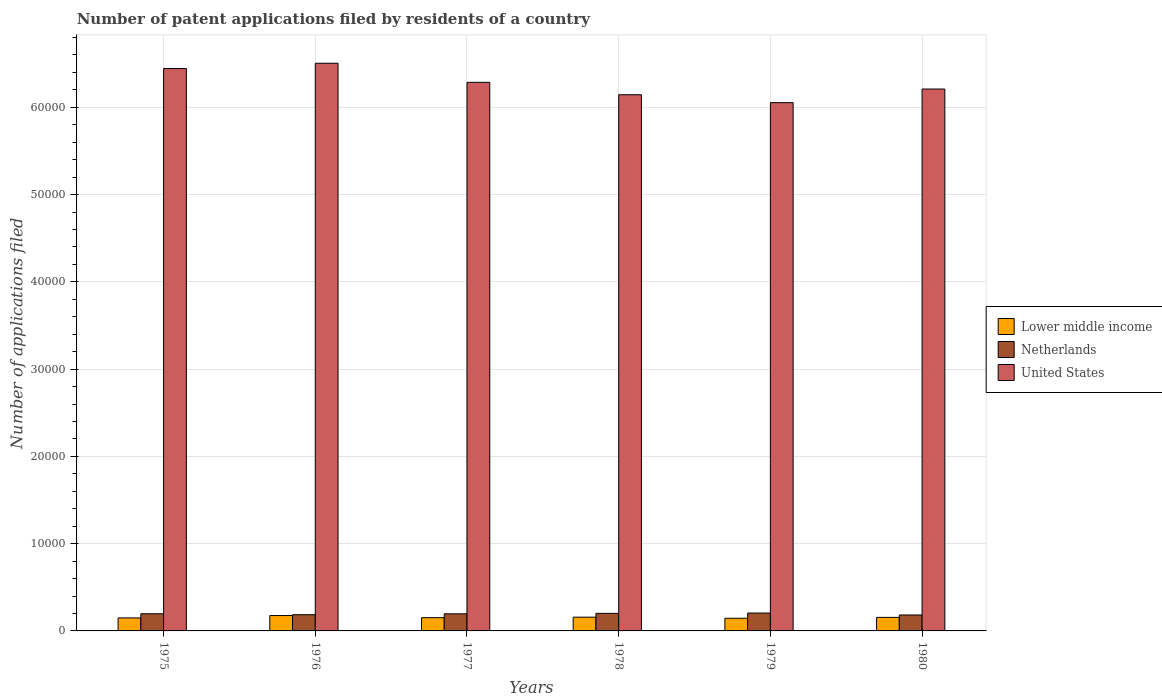How many groups of bars are there?
Make the answer very short. 6. Are the number of bars per tick equal to the number of legend labels?
Your answer should be compact. Yes. Are the number of bars on each tick of the X-axis equal?
Make the answer very short. Yes. What is the label of the 4th group of bars from the left?
Your response must be concise. 1978. In how many cases, is the number of bars for a given year not equal to the number of legend labels?
Your answer should be very brief. 0. What is the number of applications filed in Netherlands in 1976?
Give a very brief answer. 1857. Across all years, what is the maximum number of applications filed in Netherlands?
Ensure brevity in your answer.  2049. Across all years, what is the minimum number of applications filed in Lower middle income?
Provide a short and direct response. 1452. In which year was the number of applications filed in United States maximum?
Ensure brevity in your answer.  1976. In which year was the number of applications filed in United States minimum?
Your response must be concise. 1979. What is the total number of applications filed in Lower middle income in the graph?
Your answer should be compact. 9347. What is the difference between the number of applications filed in Lower middle income in 1975 and that in 1976?
Offer a terse response. -273. What is the difference between the number of applications filed in United States in 1980 and the number of applications filed in Netherlands in 1979?
Keep it short and to the point. 6.00e+04. What is the average number of applications filed in Lower middle income per year?
Your answer should be compact. 1557.83. In the year 1977, what is the difference between the number of applications filed in Netherlands and number of applications filed in United States?
Your answer should be very brief. -6.09e+04. In how many years, is the number of applications filed in United States greater than 16000?
Offer a very short reply. 6. What is the ratio of the number of applications filed in Lower middle income in 1977 to that in 1978?
Give a very brief answer. 0.96. Is the number of applications filed in Netherlands in 1978 less than that in 1979?
Offer a very short reply. Yes. Is the difference between the number of applications filed in Netherlands in 1976 and 1977 greater than the difference between the number of applications filed in United States in 1976 and 1977?
Make the answer very short. No. What is the difference between the highest and the lowest number of applications filed in Netherlands?
Make the answer very short. 223. Is the sum of the number of applications filed in Netherlands in 1977 and 1980 greater than the maximum number of applications filed in United States across all years?
Provide a succinct answer. No. What does the 2nd bar from the left in 1977 represents?
Provide a succinct answer. Netherlands. What does the 3rd bar from the right in 1977 represents?
Provide a short and direct response. Lower middle income. Are all the bars in the graph horizontal?
Keep it short and to the point. No. What is the difference between two consecutive major ticks on the Y-axis?
Ensure brevity in your answer.  10000. Are the values on the major ticks of Y-axis written in scientific E-notation?
Give a very brief answer. No. Where does the legend appear in the graph?
Provide a succinct answer. Center right. How are the legend labels stacked?
Your answer should be very brief. Vertical. What is the title of the graph?
Provide a short and direct response. Number of patent applications filed by residents of a country. Does "Andorra" appear as one of the legend labels in the graph?
Make the answer very short. No. What is the label or title of the Y-axis?
Provide a succinct answer. Number of applications filed. What is the Number of applications filed of Lower middle income in 1975?
Offer a very short reply. 1489. What is the Number of applications filed of Netherlands in 1975?
Keep it short and to the point. 1966. What is the Number of applications filed of United States in 1975?
Keep it short and to the point. 6.44e+04. What is the Number of applications filed in Lower middle income in 1976?
Ensure brevity in your answer.  1762. What is the Number of applications filed of Netherlands in 1976?
Your response must be concise. 1857. What is the Number of applications filed in United States in 1976?
Make the answer very short. 6.50e+04. What is the Number of applications filed in Lower middle income in 1977?
Keep it short and to the point. 1517. What is the Number of applications filed in Netherlands in 1977?
Offer a terse response. 1960. What is the Number of applications filed of United States in 1977?
Keep it short and to the point. 6.29e+04. What is the Number of applications filed of Lower middle income in 1978?
Give a very brief answer. 1575. What is the Number of applications filed of Netherlands in 1978?
Give a very brief answer. 2011. What is the Number of applications filed of United States in 1978?
Your answer should be very brief. 6.14e+04. What is the Number of applications filed of Lower middle income in 1979?
Provide a short and direct response. 1452. What is the Number of applications filed in Netherlands in 1979?
Provide a short and direct response. 2049. What is the Number of applications filed in United States in 1979?
Provide a succinct answer. 6.05e+04. What is the Number of applications filed of Lower middle income in 1980?
Your answer should be very brief. 1552. What is the Number of applications filed in Netherlands in 1980?
Your answer should be very brief. 1826. What is the Number of applications filed of United States in 1980?
Keep it short and to the point. 6.21e+04. Across all years, what is the maximum Number of applications filed in Lower middle income?
Keep it short and to the point. 1762. Across all years, what is the maximum Number of applications filed in Netherlands?
Give a very brief answer. 2049. Across all years, what is the maximum Number of applications filed of United States?
Your answer should be very brief. 6.50e+04. Across all years, what is the minimum Number of applications filed of Lower middle income?
Ensure brevity in your answer.  1452. Across all years, what is the minimum Number of applications filed of Netherlands?
Your answer should be very brief. 1826. Across all years, what is the minimum Number of applications filed in United States?
Provide a short and direct response. 6.05e+04. What is the total Number of applications filed of Lower middle income in the graph?
Your response must be concise. 9347. What is the total Number of applications filed of Netherlands in the graph?
Provide a short and direct response. 1.17e+04. What is the total Number of applications filed in United States in the graph?
Provide a succinct answer. 3.76e+05. What is the difference between the Number of applications filed of Lower middle income in 1975 and that in 1976?
Provide a short and direct response. -273. What is the difference between the Number of applications filed in Netherlands in 1975 and that in 1976?
Ensure brevity in your answer.  109. What is the difference between the Number of applications filed in United States in 1975 and that in 1976?
Make the answer very short. -605. What is the difference between the Number of applications filed of United States in 1975 and that in 1977?
Offer a very short reply. 1582. What is the difference between the Number of applications filed in Lower middle income in 1975 and that in 1978?
Make the answer very short. -86. What is the difference between the Number of applications filed of Netherlands in 1975 and that in 1978?
Make the answer very short. -45. What is the difference between the Number of applications filed in United States in 1975 and that in 1978?
Give a very brief answer. 3004. What is the difference between the Number of applications filed of Lower middle income in 1975 and that in 1979?
Your answer should be compact. 37. What is the difference between the Number of applications filed of Netherlands in 1975 and that in 1979?
Your answer should be compact. -83. What is the difference between the Number of applications filed in United States in 1975 and that in 1979?
Give a very brief answer. 3910. What is the difference between the Number of applications filed of Lower middle income in 1975 and that in 1980?
Your answer should be compact. -63. What is the difference between the Number of applications filed of Netherlands in 1975 and that in 1980?
Provide a succinct answer. 140. What is the difference between the Number of applications filed of United States in 1975 and that in 1980?
Ensure brevity in your answer.  2347. What is the difference between the Number of applications filed in Lower middle income in 1976 and that in 1977?
Keep it short and to the point. 245. What is the difference between the Number of applications filed in Netherlands in 1976 and that in 1977?
Make the answer very short. -103. What is the difference between the Number of applications filed of United States in 1976 and that in 1977?
Offer a very short reply. 2187. What is the difference between the Number of applications filed in Lower middle income in 1976 and that in 1978?
Offer a terse response. 187. What is the difference between the Number of applications filed of Netherlands in 1976 and that in 1978?
Offer a very short reply. -154. What is the difference between the Number of applications filed of United States in 1976 and that in 1978?
Keep it short and to the point. 3609. What is the difference between the Number of applications filed of Lower middle income in 1976 and that in 1979?
Your answer should be very brief. 310. What is the difference between the Number of applications filed in Netherlands in 1976 and that in 1979?
Make the answer very short. -192. What is the difference between the Number of applications filed of United States in 1976 and that in 1979?
Your answer should be compact. 4515. What is the difference between the Number of applications filed of Lower middle income in 1976 and that in 1980?
Ensure brevity in your answer.  210. What is the difference between the Number of applications filed of United States in 1976 and that in 1980?
Offer a very short reply. 2952. What is the difference between the Number of applications filed in Lower middle income in 1977 and that in 1978?
Your answer should be compact. -58. What is the difference between the Number of applications filed of Netherlands in 1977 and that in 1978?
Offer a very short reply. -51. What is the difference between the Number of applications filed of United States in 1977 and that in 1978?
Offer a terse response. 1422. What is the difference between the Number of applications filed of Lower middle income in 1977 and that in 1979?
Offer a very short reply. 65. What is the difference between the Number of applications filed in Netherlands in 1977 and that in 1979?
Your answer should be very brief. -89. What is the difference between the Number of applications filed of United States in 1977 and that in 1979?
Keep it short and to the point. 2328. What is the difference between the Number of applications filed of Lower middle income in 1977 and that in 1980?
Provide a short and direct response. -35. What is the difference between the Number of applications filed in Netherlands in 1977 and that in 1980?
Your response must be concise. 134. What is the difference between the Number of applications filed of United States in 1977 and that in 1980?
Offer a very short reply. 765. What is the difference between the Number of applications filed in Lower middle income in 1978 and that in 1979?
Provide a succinct answer. 123. What is the difference between the Number of applications filed in Netherlands in 1978 and that in 1979?
Offer a terse response. -38. What is the difference between the Number of applications filed in United States in 1978 and that in 1979?
Your response must be concise. 906. What is the difference between the Number of applications filed in Lower middle income in 1978 and that in 1980?
Give a very brief answer. 23. What is the difference between the Number of applications filed in Netherlands in 1978 and that in 1980?
Offer a terse response. 185. What is the difference between the Number of applications filed of United States in 1978 and that in 1980?
Your response must be concise. -657. What is the difference between the Number of applications filed of Lower middle income in 1979 and that in 1980?
Ensure brevity in your answer.  -100. What is the difference between the Number of applications filed of Netherlands in 1979 and that in 1980?
Ensure brevity in your answer.  223. What is the difference between the Number of applications filed in United States in 1979 and that in 1980?
Provide a succinct answer. -1563. What is the difference between the Number of applications filed in Lower middle income in 1975 and the Number of applications filed in Netherlands in 1976?
Offer a very short reply. -368. What is the difference between the Number of applications filed in Lower middle income in 1975 and the Number of applications filed in United States in 1976?
Provide a succinct answer. -6.36e+04. What is the difference between the Number of applications filed in Netherlands in 1975 and the Number of applications filed in United States in 1976?
Offer a terse response. -6.31e+04. What is the difference between the Number of applications filed of Lower middle income in 1975 and the Number of applications filed of Netherlands in 1977?
Your response must be concise. -471. What is the difference between the Number of applications filed of Lower middle income in 1975 and the Number of applications filed of United States in 1977?
Your answer should be compact. -6.14e+04. What is the difference between the Number of applications filed in Netherlands in 1975 and the Number of applications filed in United States in 1977?
Your answer should be compact. -6.09e+04. What is the difference between the Number of applications filed in Lower middle income in 1975 and the Number of applications filed in Netherlands in 1978?
Keep it short and to the point. -522. What is the difference between the Number of applications filed of Lower middle income in 1975 and the Number of applications filed of United States in 1978?
Ensure brevity in your answer.  -6.00e+04. What is the difference between the Number of applications filed in Netherlands in 1975 and the Number of applications filed in United States in 1978?
Offer a very short reply. -5.95e+04. What is the difference between the Number of applications filed in Lower middle income in 1975 and the Number of applications filed in Netherlands in 1979?
Your answer should be very brief. -560. What is the difference between the Number of applications filed of Lower middle income in 1975 and the Number of applications filed of United States in 1979?
Keep it short and to the point. -5.90e+04. What is the difference between the Number of applications filed in Netherlands in 1975 and the Number of applications filed in United States in 1979?
Provide a succinct answer. -5.86e+04. What is the difference between the Number of applications filed of Lower middle income in 1975 and the Number of applications filed of Netherlands in 1980?
Offer a terse response. -337. What is the difference between the Number of applications filed in Lower middle income in 1975 and the Number of applications filed in United States in 1980?
Make the answer very short. -6.06e+04. What is the difference between the Number of applications filed of Netherlands in 1975 and the Number of applications filed of United States in 1980?
Keep it short and to the point. -6.01e+04. What is the difference between the Number of applications filed of Lower middle income in 1976 and the Number of applications filed of Netherlands in 1977?
Offer a terse response. -198. What is the difference between the Number of applications filed in Lower middle income in 1976 and the Number of applications filed in United States in 1977?
Your answer should be very brief. -6.11e+04. What is the difference between the Number of applications filed of Netherlands in 1976 and the Number of applications filed of United States in 1977?
Make the answer very short. -6.10e+04. What is the difference between the Number of applications filed of Lower middle income in 1976 and the Number of applications filed of Netherlands in 1978?
Your answer should be compact. -249. What is the difference between the Number of applications filed in Lower middle income in 1976 and the Number of applications filed in United States in 1978?
Your response must be concise. -5.97e+04. What is the difference between the Number of applications filed in Netherlands in 1976 and the Number of applications filed in United States in 1978?
Provide a short and direct response. -5.96e+04. What is the difference between the Number of applications filed of Lower middle income in 1976 and the Number of applications filed of Netherlands in 1979?
Give a very brief answer. -287. What is the difference between the Number of applications filed in Lower middle income in 1976 and the Number of applications filed in United States in 1979?
Your answer should be compact. -5.88e+04. What is the difference between the Number of applications filed of Netherlands in 1976 and the Number of applications filed of United States in 1979?
Your answer should be very brief. -5.87e+04. What is the difference between the Number of applications filed in Lower middle income in 1976 and the Number of applications filed in Netherlands in 1980?
Your answer should be very brief. -64. What is the difference between the Number of applications filed in Lower middle income in 1976 and the Number of applications filed in United States in 1980?
Your response must be concise. -6.03e+04. What is the difference between the Number of applications filed in Netherlands in 1976 and the Number of applications filed in United States in 1980?
Your answer should be compact. -6.02e+04. What is the difference between the Number of applications filed in Lower middle income in 1977 and the Number of applications filed in Netherlands in 1978?
Give a very brief answer. -494. What is the difference between the Number of applications filed in Lower middle income in 1977 and the Number of applications filed in United States in 1978?
Your response must be concise. -5.99e+04. What is the difference between the Number of applications filed of Netherlands in 1977 and the Number of applications filed of United States in 1978?
Provide a short and direct response. -5.95e+04. What is the difference between the Number of applications filed of Lower middle income in 1977 and the Number of applications filed of Netherlands in 1979?
Offer a very short reply. -532. What is the difference between the Number of applications filed in Lower middle income in 1977 and the Number of applications filed in United States in 1979?
Your answer should be compact. -5.90e+04. What is the difference between the Number of applications filed in Netherlands in 1977 and the Number of applications filed in United States in 1979?
Keep it short and to the point. -5.86e+04. What is the difference between the Number of applications filed of Lower middle income in 1977 and the Number of applications filed of Netherlands in 1980?
Give a very brief answer. -309. What is the difference between the Number of applications filed in Lower middle income in 1977 and the Number of applications filed in United States in 1980?
Provide a short and direct response. -6.06e+04. What is the difference between the Number of applications filed in Netherlands in 1977 and the Number of applications filed in United States in 1980?
Your answer should be very brief. -6.01e+04. What is the difference between the Number of applications filed of Lower middle income in 1978 and the Number of applications filed of Netherlands in 1979?
Offer a terse response. -474. What is the difference between the Number of applications filed in Lower middle income in 1978 and the Number of applications filed in United States in 1979?
Give a very brief answer. -5.90e+04. What is the difference between the Number of applications filed in Netherlands in 1978 and the Number of applications filed in United States in 1979?
Provide a succinct answer. -5.85e+04. What is the difference between the Number of applications filed in Lower middle income in 1978 and the Number of applications filed in Netherlands in 1980?
Your response must be concise. -251. What is the difference between the Number of applications filed in Lower middle income in 1978 and the Number of applications filed in United States in 1980?
Your response must be concise. -6.05e+04. What is the difference between the Number of applications filed in Netherlands in 1978 and the Number of applications filed in United States in 1980?
Your answer should be compact. -6.01e+04. What is the difference between the Number of applications filed of Lower middle income in 1979 and the Number of applications filed of Netherlands in 1980?
Your response must be concise. -374. What is the difference between the Number of applications filed in Lower middle income in 1979 and the Number of applications filed in United States in 1980?
Your answer should be compact. -6.06e+04. What is the difference between the Number of applications filed of Netherlands in 1979 and the Number of applications filed of United States in 1980?
Make the answer very short. -6.00e+04. What is the average Number of applications filed in Lower middle income per year?
Provide a short and direct response. 1557.83. What is the average Number of applications filed in Netherlands per year?
Give a very brief answer. 1944.83. What is the average Number of applications filed in United States per year?
Give a very brief answer. 6.27e+04. In the year 1975, what is the difference between the Number of applications filed of Lower middle income and Number of applications filed of Netherlands?
Make the answer very short. -477. In the year 1975, what is the difference between the Number of applications filed of Lower middle income and Number of applications filed of United States?
Make the answer very short. -6.30e+04. In the year 1975, what is the difference between the Number of applications filed of Netherlands and Number of applications filed of United States?
Ensure brevity in your answer.  -6.25e+04. In the year 1976, what is the difference between the Number of applications filed in Lower middle income and Number of applications filed in Netherlands?
Ensure brevity in your answer.  -95. In the year 1976, what is the difference between the Number of applications filed in Lower middle income and Number of applications filed in United States?
Your answer should be compact. -6.33e+04. In the year 1976, what is the difference between the Number of applications filed in Netherlands and Number of applications filed in United States?
Offer a terse response. -6.32e+04. In the year 1977, what is the difference between the Number of applications filed in Lower middle income and Number of applications filed in Netherlands?
Offer a terse response. -443. In the year 1977, what is the difference between the Number of applications filed of Lower middle income and Number of applications filed of United States?
Keep it short and to the point. -6.13e+04. In the year 1977, what is the difference between the Number of applications filed of Netherlands and Number of applications filed of United States?
Make the answer very short. -6.09e+04. In the year 1978, what is the difference between the Number of applications filed in Lower middle income and Number of applications filed in Netherlands?
Your answer should be very brief. -436. In the year 1978, what is the difference between the Number of applications filed of Lower middle income and Number of applications filed of United States?
Offer a terse response. -5.99e+04. In the year 1978, what is the difference between the Number of applications filed of Netherlands and Number of applications filed of United States?
Provide a succinct answer. -5.94e+04. In the year 1979, what is the difference between the Number of applications filed in Lower middle income and Number of applications filed in Netherlands?
Your response must be concise. -597. In the year 1979, what is the difference between the Number of applications filed of Lower middle income and Number of applications filed of United States?
Offer a very short reply. -5.91e+04. In the year 1979, what is the difference between the Number of applications filed of Netherlands and Number of applications filed of United States?
Give a very brief answer. -5.85e+04. In the year 1980, what is the difference between the Number of applications filed of Lower middle income and Number of applications filed of Netherlands?
Provide a short and direct response. -274. In the year 1980, what is the difference between the Number of applications filed in Lower middle income and Number of applications filed in United States?
Make the answer very short. -6.05e+04. In the year 1980, what is the difference between the Number of applications filed in Netherlands and Number of applications filed in United States?
Offer a terse response. -6.03e+04. What is the ratio of the Number of applications filed in Lower middle income in 1975 to that in 1976?
Offer a terse response. 0.85. What is the ratio of the Number of applications filed in Netherlands in 1975 to that in 1976?
Your answer should be very brief. 1.06. What is the ratio of the Number of applications filed of United States in 1975 to that in 1976?
Offer a terse response. 0.99. What is the ratio of the Number of applications filed of Lower middle income in 1975 to that in 1977?
Give a very brief answer. 0.98. What is the ratio of the Number of applications filed of Netherlands in 1975 to that in 1977?
Your answer should be very brief. 1. What is the ratio of the Number of applications filed of United States in 1975 to that in 1977?
Your answer should be very brief. 1.03. What is the ratio of the Number of applications filed of Lower middle income in 1975 to that in 1978?
Ensure brevity in your answer.  0.95. What is the ratio of the Number of applications filed in Netherlands in 1975 to that in 1978?
Ensure brevity in your answer.  0.98. What is the ratio of the Number of applications filed of United States in 1975 to that in 1978?
Your response must be concise. 1.05. What is the ratio of the Number of applications filed of Lower middle income in 1975 to that in 1979?
Your response must be concise. 1.03. What is the ratio of the Number of applications filed of Netherlands in 1975 to that in 1979?
Offer a terse response. 0.96. What is the ratio of the Number of applications filed in United States in 1975 to that in 1979?
Offer a terse response. 1.06. What is the ratio of the Number of applications filed of Lower middle income in 1975 to that in 1980?
Offer a very short reply. 0.96. What is the ratio of the Number of applications filed of Netherlands in 1975 to that in 1980?
Provide a short and direct response. 1.08. What is the ratio of the Number of applications filed of United States in 1975 to that in 1980?
Ensure brevity in your answer.  1.04. What is the ratio of the Number of applications filed of Lower middle income in 1976 to that in 1977?
Provide a short and direct response. 1.16. What is the ratio of the Number of applications filed in United States in 1976 to that in 1977?
Ensure brevity in your answer.  1.03. What is the ratio of the Number of applications filed in Lower middle income in 1976 to that in 1978?
Give a very brief answer. 1.12. What is the ratio of the Number of applications filed of Netherlands in 1976 to that in 1978?
Ensure brevity in your answer.  0.92. What is the ratio of the Number of applications filed in United States in 1976 to that in 1978?
Provide a succinct answer. 1.06. What is the ratio of the Number of applications filed in Lower middle income in 1976 to that in 1979?
Offer a terse response. 1.21. What is the ratio of the Number of applications filed in Netherlands in 1976 to that in 1979?
Your response must be concise. 0.91. What is the ratio of the Number of applications filed of United States in 1976 to that in 1979?
Offer a very short reply. 1.07. What is the ratio of the Number of applications filed of Lower middle income in 1976 to that in 1980?
Keep it short and to the point. 1.14. What is the ratio of the Number of applications filed of Netherlands in 1976 to that in 1980?
Keep it short and to the point. 1.02. What is the ratio of the Number of applications filed in United States in 1976 to that in 1980?
Make the answer very short. 1.05. What is the ratio of the Number of applications filed of Lower middle income in 1977 to that in 1978?
Make the answer very short. 0.96. What is the ratio of the Number of applications filed in Netherlands in 1977 to that in 1978?
Give a very brief answer. 0.97. What is the ratio of the Number of applications filed of United States in 1977 to that in 1978?
Your response must be concise. 1.02. What is the ratio of the Number of applications filed in Lower middle income in 1977 to that in 1979?
Your answer should be compact. 1.04. What is the ratio of the Number of applications filed in Netherlands in 1977 to that in 1979?
Your answer should be compact. 0.96. What is the ratio of the Number of applications filed in Lower middle income in 1977 to that in 1980?
Your response must be concise. 0.98. What is the ratio of the Number of applications filed in Netherlands in 1977 to that in 1980?
Keep it short and to the point. 1.07. What is the ratio of the Number of applications filed in United States in 1977 to that in 1980?
Your answer should be compact. 1.01. What is the ratio of the Number of applications filed of Lower middle income in 1978 to that in 1979?
Ensure brevity in your answer.  1.08. What is the ratio of the Number of applications filed in Netherlands in 1978 to that in 1979?
Make the answer very short. 0.98. What is the ratio of the Number of applications filed in Lower middle income in 1978 to that in 1980?
Your answer should be compact. 1.01. What is the ratio of the Number of applications filed of Netherlands in 1978 to that in 1980?
Offer a very short reply. 1.1. What is the ratio of the Number of applications filed of Lower middle income in 1979 to that in 1980?
Provide a succinct answer. 0.94. What is the ratio of the Number of applications filed of Netherlands in 1979 to that in 1980?
Your answer should be compact. 1.12. What is the ratio of the Number of applications filed in United States in 1979 to that in 1980?
Your response must be concise. 0.97. What is the difference between the highest and the second highest Number of applications filed of Lower middle income?
Your answer should be very brief. 187. What is the difference between the highest and the second highest Number of applications filed of United States?
Your answer should be very brief. 605. What is the difference between the highest and the lowest Number of applications filed in Lower middle income?
Your answer should be very brief. 310. What is the difference between the highest and the lowest Number of applications filed in Netherlands?
Ensure brevity in your answer.  223. What is the difference between the highest and the lowest Number of applications filed in United States?
Ensure brevity in your answer.  4515. 